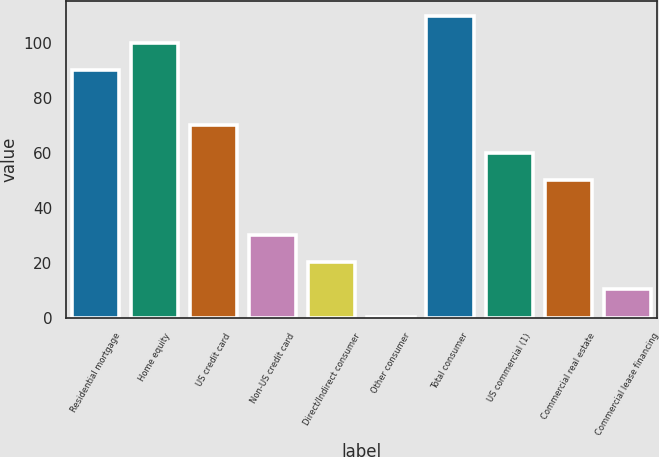Convert chart to OTSL. <chart><loc_0><loc_0><loc_500><loc_500><bar_chart><fcel>Residential mortgage<fcel>Home equity<fcel>US credit card<fcel>Non-US credit card<fcel>Direct/Indirect consumer<fcel>Other consumer<fcel>Total consumer<fcel>US commercial (1)<fcel>Commercial real estate<fcel>Commercial lease financing<nl><fcel>90.04<fcel>99.98<fcel>70.16<fcel>30.4<fcel>20.46<fcel>0.58<fcel>109.92<fcel>60.22<fcel>50.28<fcel>10.52<nl></chart> 